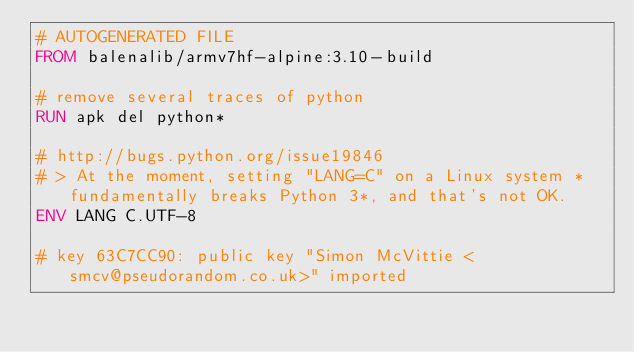<code> <loc_0><loc_0><loc_500><loc_500><_Dockerfile_># AUTOGENERATED FILE
FROM balenalib/armv7hf-alpine:3.10-build

# remove several traces of python
RUN apk del python*

# http://bugs.python.org/issue19846
# > At the moment, setting "LANG=C" on a Linux system *fundamentally breaks Python 3*, and that's not OK.
ENV LANG C.UTF-8

# key 63C7CC90: public key "Simon McVittie <smcv@pseudorandom.co.uk>" imported</code> 